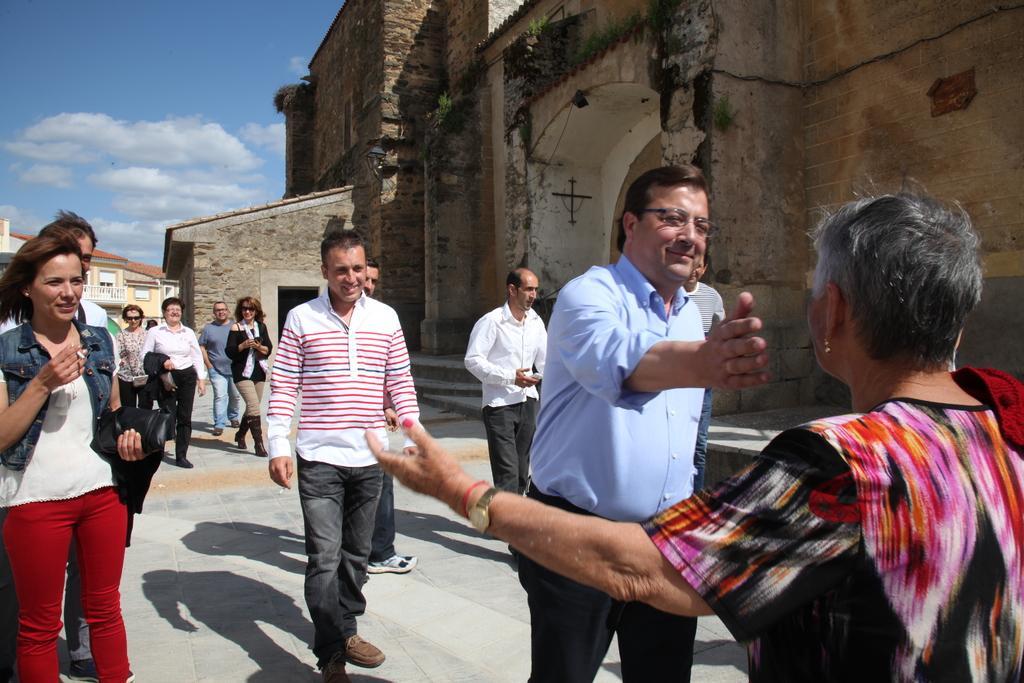Describe this image in one or two sentences. In this image we can see there are a few people standing and walking on the road. In the background there are buildings and sky. 